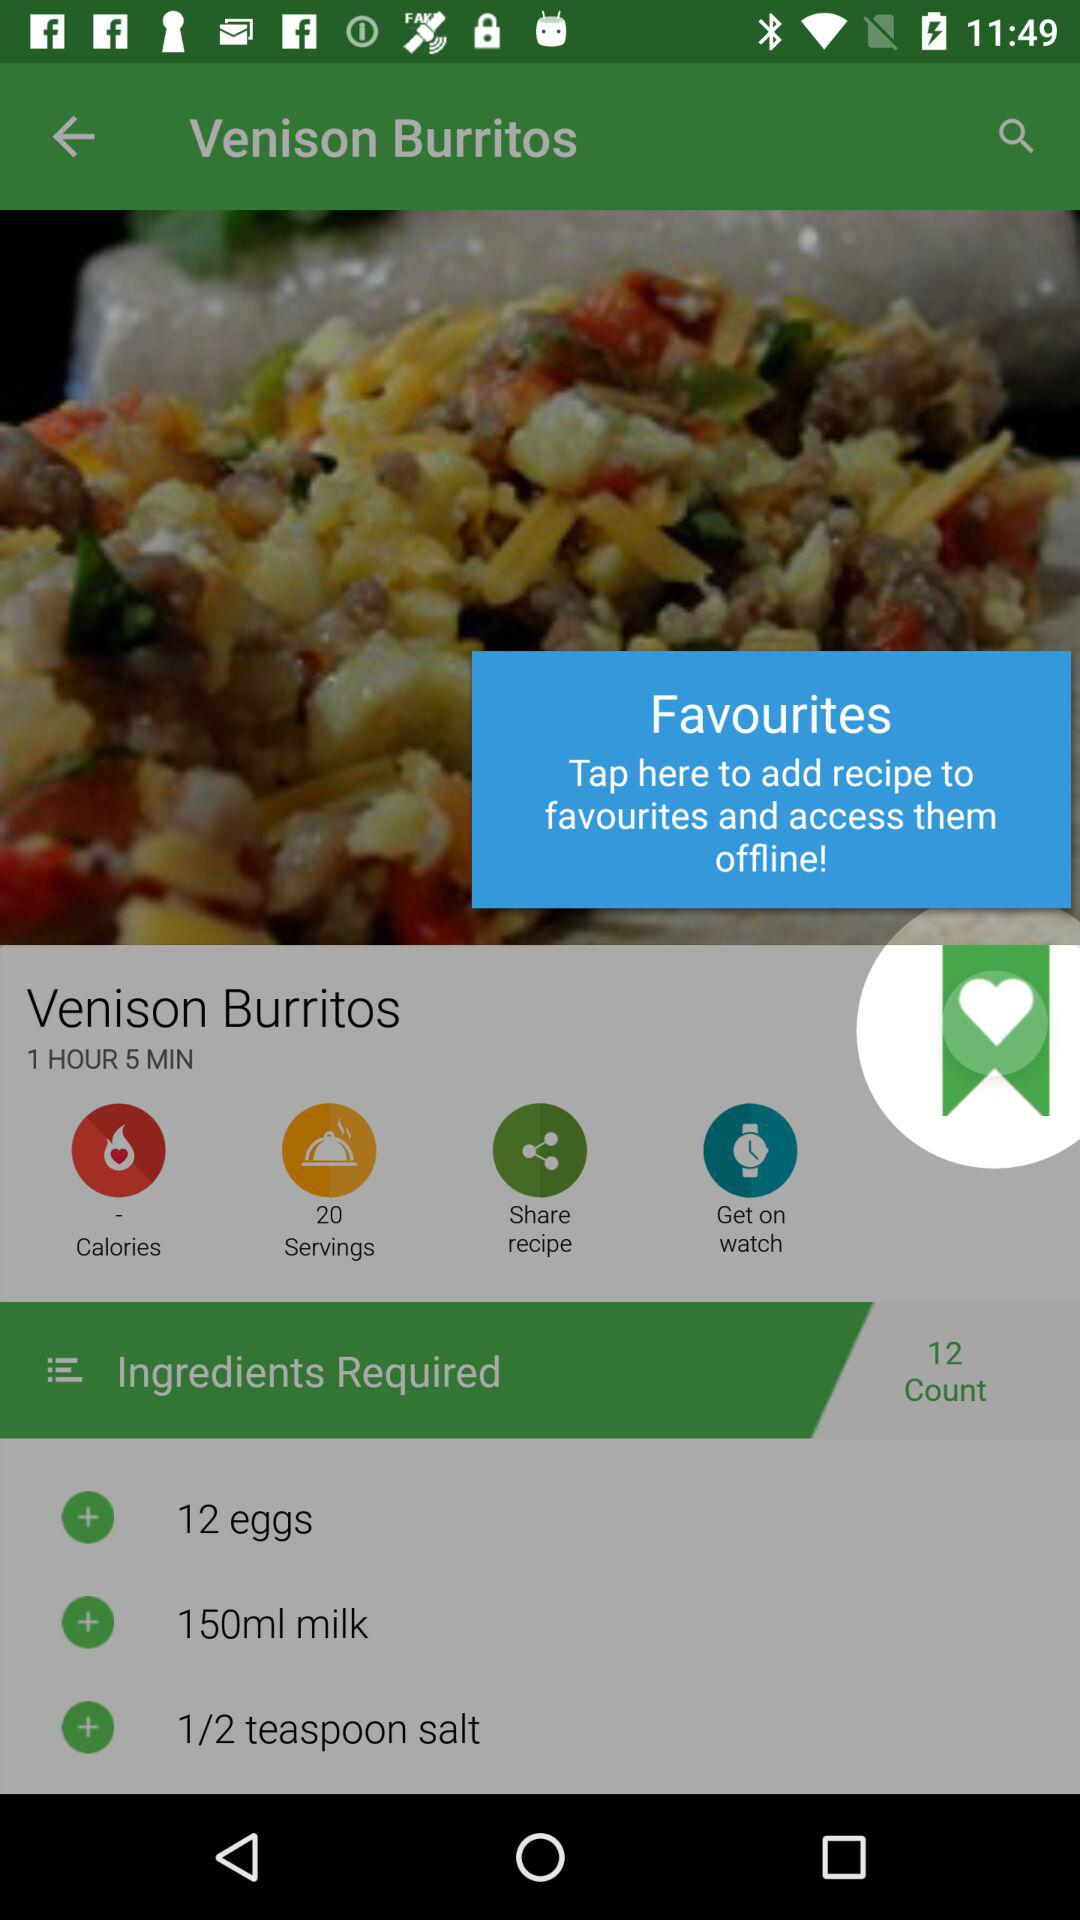What amount of milk is required? The amount of milk required is 150 ml. 